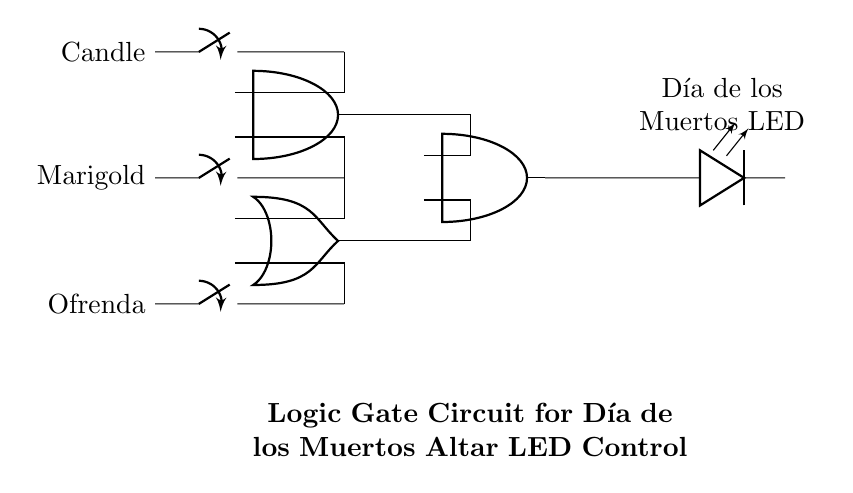What are the main components in this circuit? The main components in the circuit are the switches (Candle, Marigold, Ofrenda), logic gates (AND and OR), and the LED display for Día de los Muertos.
Answer: switches, logic gates, LED How many switches are present in the circuit? There are three switches, each corresponding to a different input for the logic gates. They are labeled as Candle, Marigold, and Ofrenda.
Answer: three What logical operation does the first logic gate perform? The first logic gate in the circuit is an AND gate, which combines inputs from the Candle and Marigold switches. The output will only be high if both inputs are active.
Answer: AND Which switches influence the OR gate? The OR gate is influenced by the Ofrenda switch and also receives input from the Marigold switch. It outputs a high signal if at least one of these switches is on.
Answer: Ofrenda, Marigold What is the final output of this circuit? The final output of the circuit is an LED display that lights up when the AND gate and the OR gate both produce a high output, indicating specific combinations of the switches are active.
Answer: LED display 